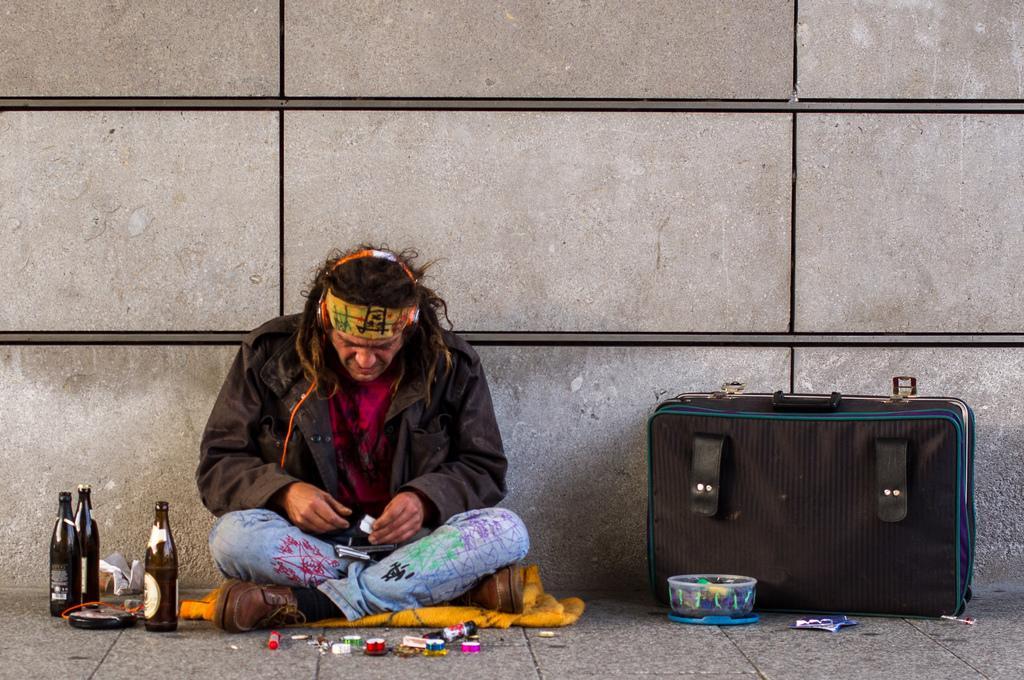Can you describe this image briefly? Here we can see one man sitting on the floor and we can see a blanket here. Beside to him we can see bottles, papers, marker, colour tapes and also a luggage suitcase and a box. 